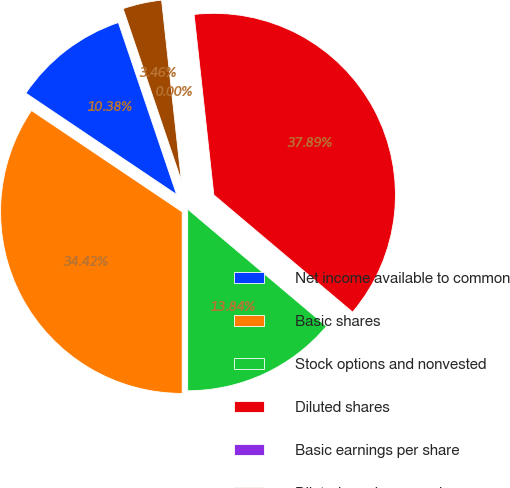Convert chart to OTSL. <chart><loc_0><loc_0><loc_500><loc_500><pie_chart><fcel>Net income available to common<fcel>Basic shares<fcel>Stock options and nonvested<fcel>Diluted shares<fcel>Basic earnings per share<fcel>Diluted earnings per share<nl><fcel>10.38%<fcel>34.42%<fcel>13.84%<fcel>37.89%<fcel>0.0%<fcel>3.46%<nl></chart> 